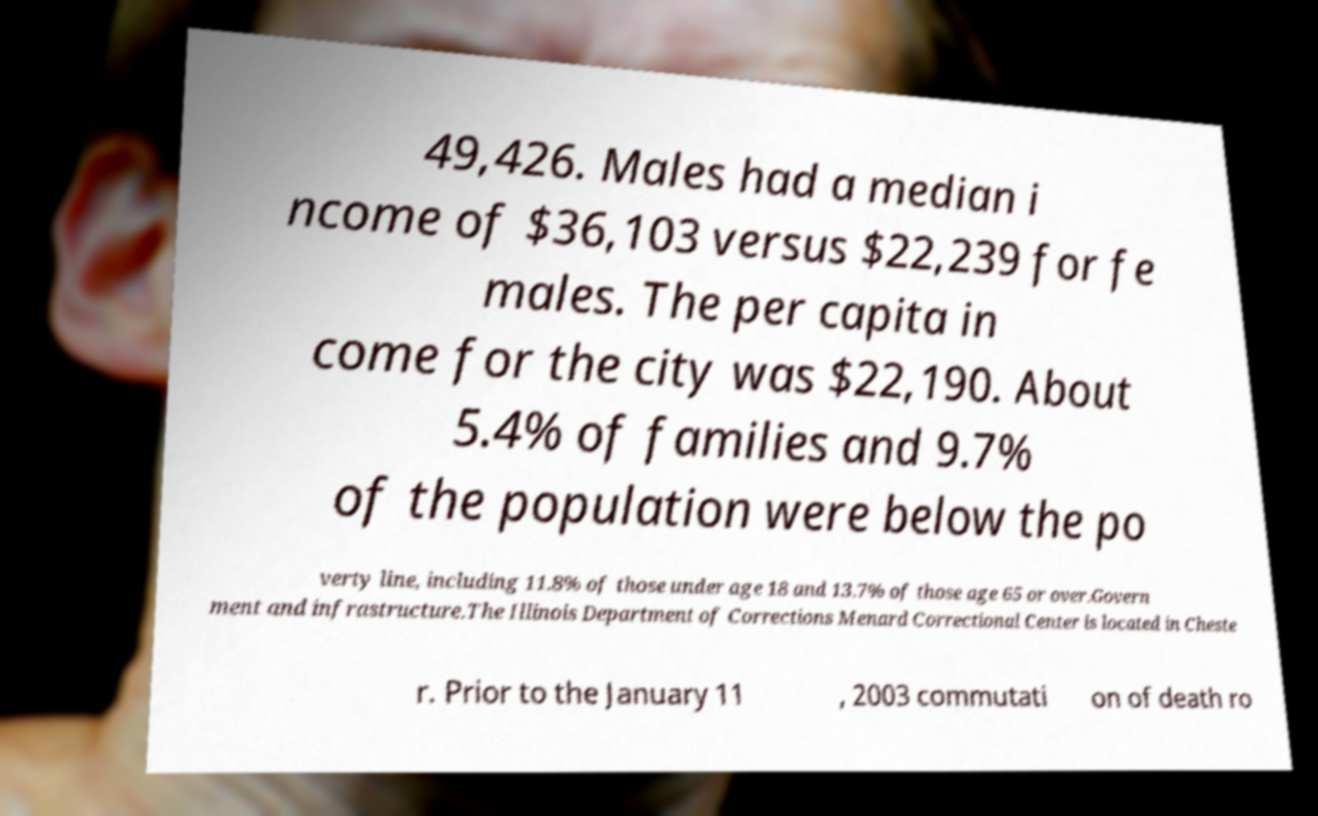There's text embedded in this image that I need extracted. Can you transcribe it verbatim? 49,426. Males had a median i ncome of $36,103 versus $22,239 for fe males. The per capita in come for the city was $22,190. About 5.4% of families and 9.7% of the population were below the po verty line, including 11.8% of those under age 18 and 13.7% of those age 65 or over.Govern ment and infrastructure.The Illinois Department of Corrections Menard Correctional Center is located in Cheste r. Prior to the January 11 , 2003 commutati on of death ro 